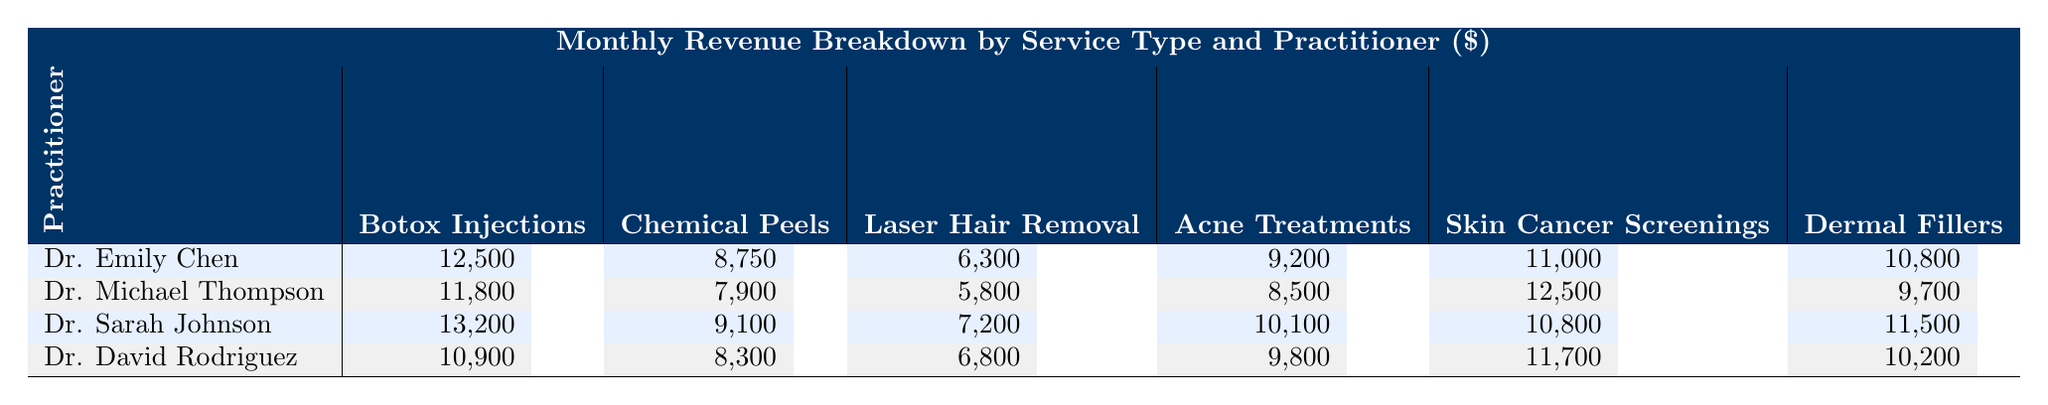What is the revenue generated by Dr. Sarah Johnson for Chemical Peels? The table shows that Dr. Sarah Johnson generated \$9,100 for Chemical Peels.
Answer: \$9,100 Which practitioner earned the most from Botox Injections? Reviewing the table, Dr. Sarah Johnson earned the highest amount at \$13,200 for Botox Injections.
Answer: Dr. Sarah Johnson What is the total revenue from Skin Cancer Screenings across all practitioners? By summing the values for Skin Cancer Screenings from all practitioners: 11,000 + 12,500 + 10,800 + 11,700 = 46,000.
Answer: \$46,000 Did Dr. Emily Chen make more from Acne Treatments than Dr. Michael Thompson? Dr. Emily Chen's revenue for Acne Treatments is \$9,200 while Dr. Michael Thompson's is \$8,500. Thus, Dr. Emily Chen made more.
Answer: Yes What is the average revenue generated by Dr. David Rodriguez across all services? Summing Dr. David Rodriguez's revenue: 10,900 + 8,300 + 6,800 + 9,800 + 11,700 + 10,200 = 57,000. Dividing by 6 services gives an average of 57,000 / 6 = 9,500.
Answer: \$9,500 Which service brought in the least revenue for Dr. Michael Thompson? Among the revenue amounts for Dr. Michael Thompson, Laser Hair Removal at \$5,800 is the lowest.
Answer: Laser Hair Removal How much more did Dr. Emily Chen earn from Dermal Fillers compared to Dr. David Rodriguez? Dr. Emily Chen earned \$10,800 and Dr. David Rodriguez earned \$10,200 for Dermal Fillers. The difference is \$10,800 - \$10,200 = \$600.
Answer: \$600 Which practitioner had the highest total revenue across all services? Calculating total revenues: Dr. Emily Chen = 12,500 + 8,750 + 6,300 + 9,200 + 11,000 + 10,800 = 58,550; Dr. Michael Thompson = 11,800 + 7,900 + 5,800 + 8,500 + 12,500 + 9,700 = 56,200; Dr. Sarah Johnson = 13,200 + 9,100 + 7,200 + 10,100 + 10,800 + 11,500 = 61,100; Dr. David Rodriguez = 10,900 + 8,300 + 6,800 + 9,800 + 11,700 + 10,200 = 57,000. Dr. Sarah Johnson has the highest total of \$61,100.
Answer: Dr. Sarah Johnson Is the total revenue from Acne Treatments greater than that from Chemical Peels across all practitioners combined? Acne Treatments total: 9,200 + 8,500 + 10,100 + 9,800 = 37,600; Chemical Peels total: 8,750 + 7,900 + 9,100 + 8,300 = 34,050. Since 37,600 > 34,050, the answer is yes.
Answer: Yes 